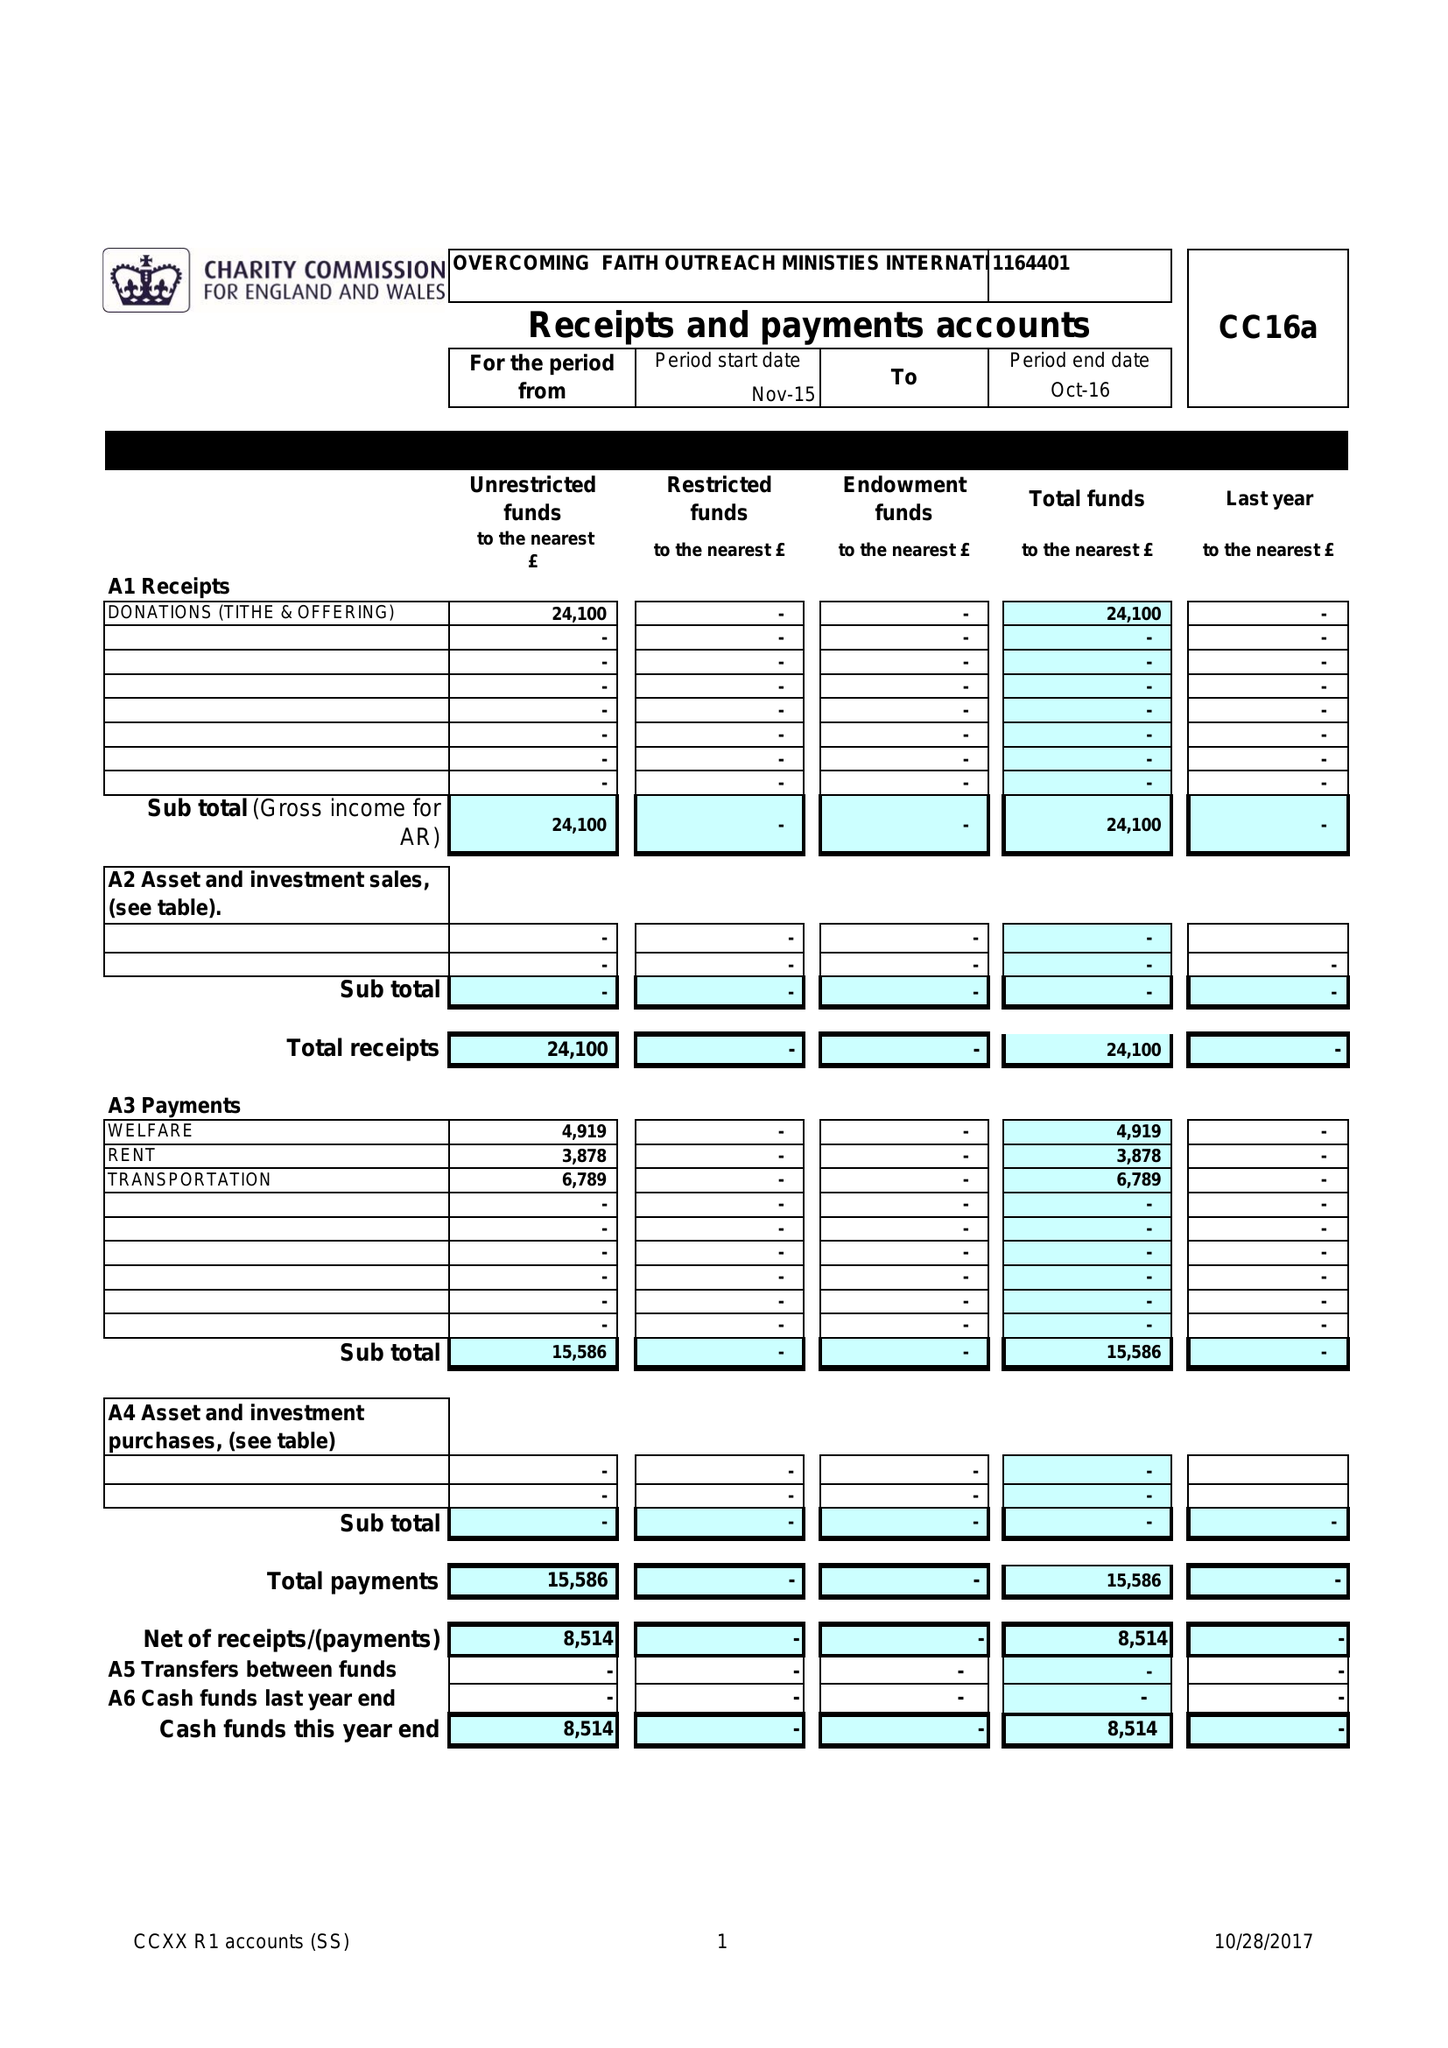What is the value for the address__post_town?
Answer the question using a single word or phrase. ROMFORD 